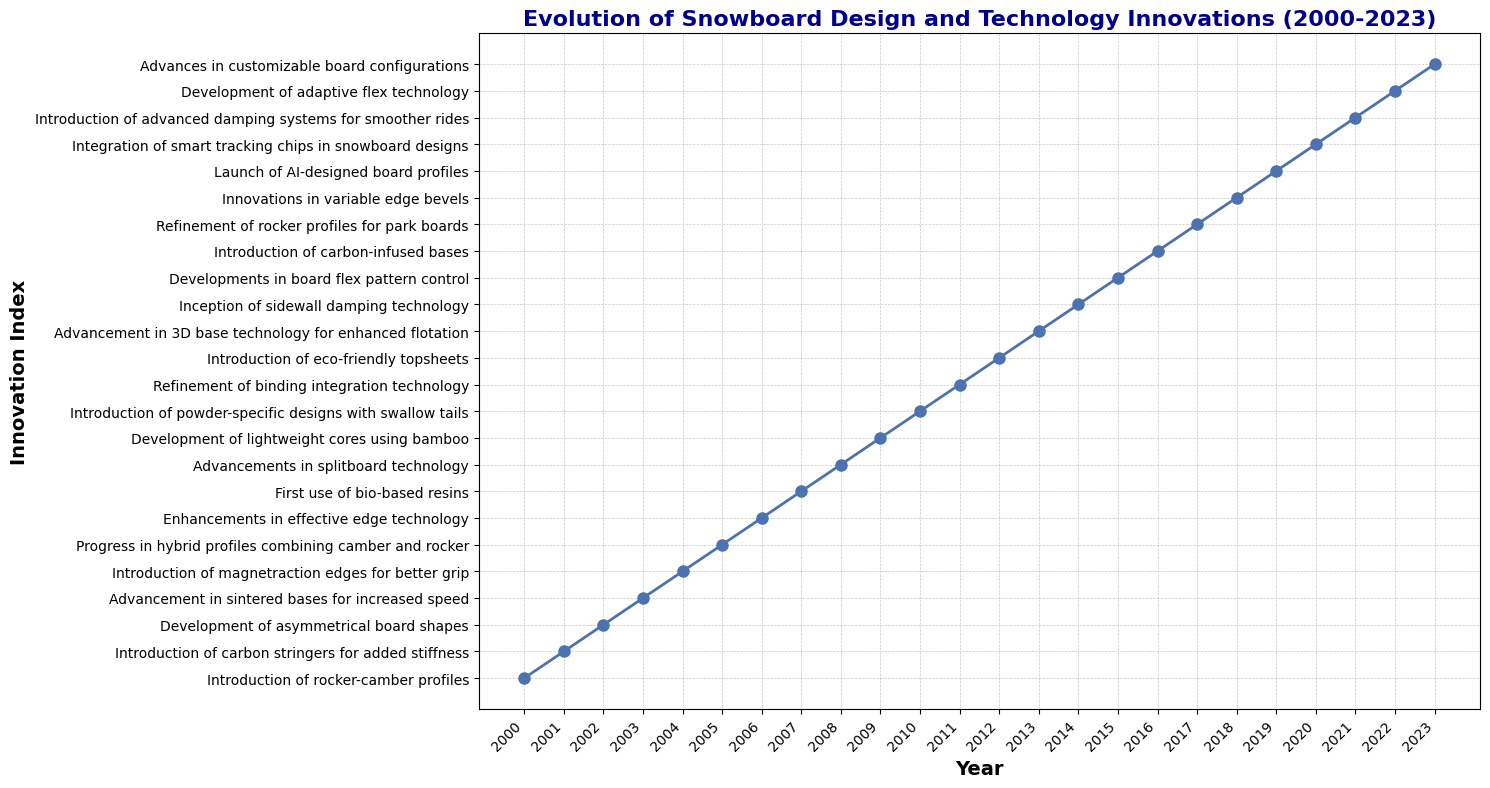When was the introduction of rocker-camber profiles? Look at the earliest point on the x-axis labeled "2000." The corresponding innovation is "Introduction of rocker-camber profiles."
Answer: 2000 Which innovation was introduced in 2015? Find the point labeled "2015" on the x-axis. The corresponding innovation is "Developments in board flex pattern control."
Answer: Developments in board flex pattern control Did carbon-infused bases or advancements in 3D base technology come first? Compare the x-axis labels for "Introduction of carbon-infused bases" (2016) and "Advancement in 3D base technology for enhanced flotation" (2013).
Answer: Advancements in 3D base technology for enhanced flotation What patterns can you observe in snowboard innovations between 2010 and 2015? Look at the x-axis from 2010 to 2015, noting the innovations. The sequence is "Introduction of powder-specific designs with swallow tails" (2010), "Refinement of binding integration technology" (2011), "Introduction of eco-friendly topsheets" (2012), "Advancement in 3D base technology for enhanced flotation" (2013), "Inception of sidewall damping technology" (2014), and "Developments in board flex pattern control" (2015).
Answer: Multiple new design and material improvements were introduced sequentially during 2010-2015 How many innovations were introduced between 2000 and 2009? Count the innovations from 2000 to 2009: "Introduction of rocker-camber profiles" (2000), "Introduction of carbon stringers for added stiffness" (2001), "Development of asymmetrical board shapes" (2002), "Advancement in sintered bases for increased speed" (2003), "Introduction of magnetraction edges for better grip" (2004), "Progress in hybrid profiles combining camber and rocker" (2005), "Enhancements in effective edge technology" (2006), "First use of bio-based resins" (2007), "Advancements in splitboard technology" (2008), and "Development of lightweight cores using bamboo" (2009). There are 10 innovations.
Answer: 10 Between which two consecutive years is the greatest visual gap on the innovation index? Examine the distances between consecutive points on the line chart. Identify the largest gap visually. This occurs between "2003" (Advancement in sintered bases for increased speed) and "2004" (Introduction of magnetraction edges for better grip).
Answer: 2003-2004 What is the median year for the listed innovations? Since there are 24 years (2000 to 2023), calculate the median position as (24+1)/2 = 12.5. The median falls between the 12th and 13th points, which are "2011" and "2012". Thus, the median year is the average of 2011 and 2012.
Answer: 2011.5 Which innovation directly follows eco-friendly topsheets? Locate "Introduction of eco-friendly topsheets" at 2012. The next year, 2013, lists "Advancement in 3D base technology for enhanced flotation."
Answer: Advancement in 3D base technology for enhanced flotation 